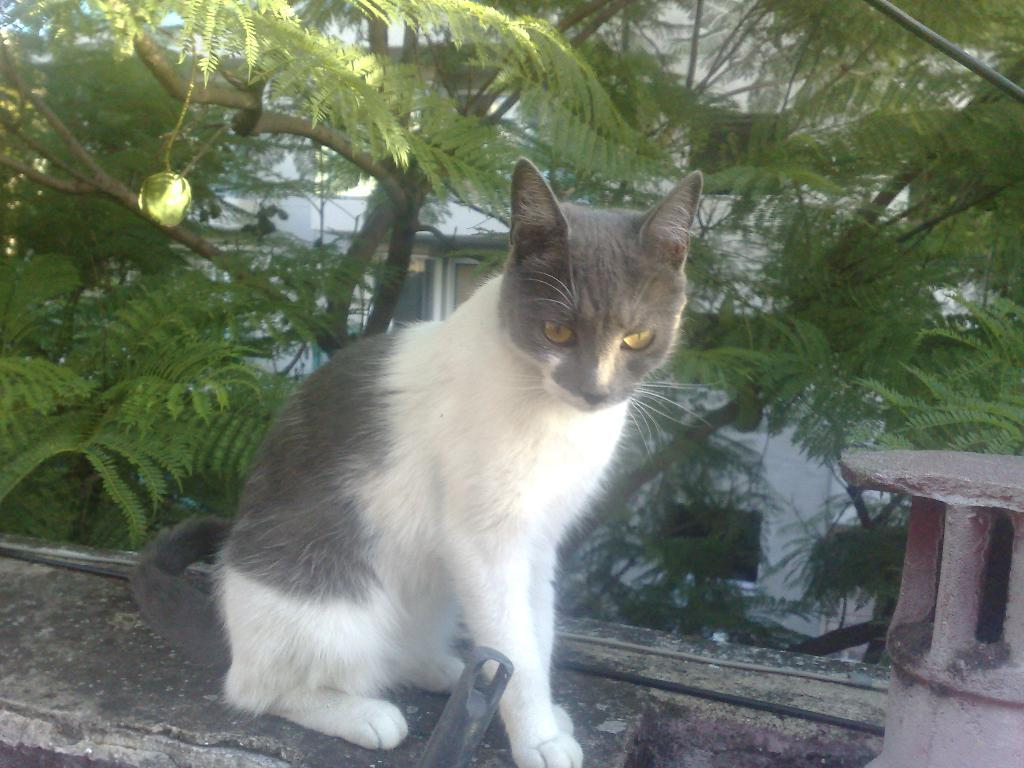What animal is present in the image? There is a cat in the image. Where is the cat located? The cat is sitting on a wall. What can be seen behind the cat? There is a tree visible behind the cat. What type of structure is in the background of the image? There is a white building in the background of the image. What part of the sky is visible in the image? The sky is visible in the top left corner of the image. What type of nail is the cat using to climb the wall in the image? There is no nail present in the image, and the cat is not climbing the wall; it is sitting on it. 